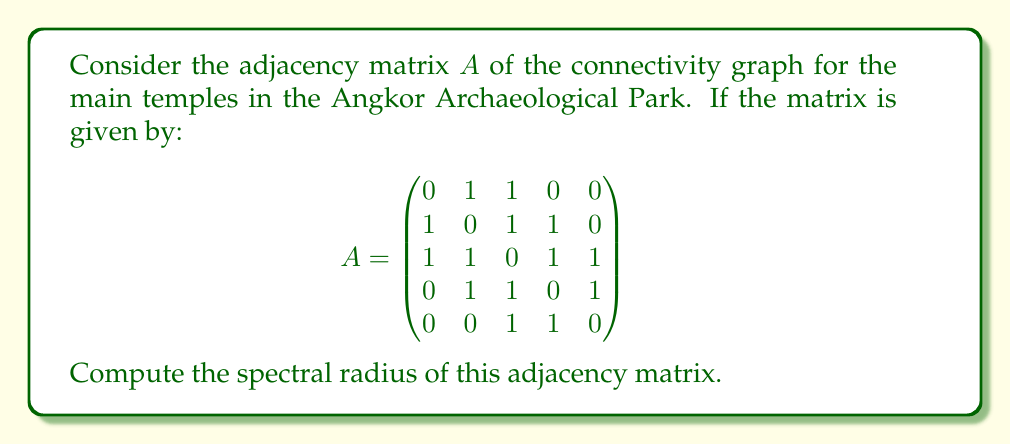Can you answer this question? To find the spectral radius of the adjacency matrix $A$, we need to follow these steps:

1) The spectral radius is the largest absolute value of the eigenvalues of $A$.

2) To find the eigenvalues, we need to solve the characteristic equation:
   $\det(A - \lambda I) = 0$

3) Expanding the determinant:
   $$\det\begin{pmatrix}
   -\lambda & 1 & 1 & 0 & 0 \\
   1 & -\lambda & 1 & 1 & 0 \\
   1 & 1 & -\lambda & 1 & 1 \\
   0 & 1 & 1 & -\lambda & 1 \\
   0 & 0 & 1 & 1 & -\lambda
   \end{pmatrix} = 0$$

4) This yields the characteristic polynomial:
   $\lambda^5 - 7\lambda^3 - 4\lambda^2 + 3\lambda + 1 = 0$

5) The roots of this polynomial are the eigenvalues. While finding the exact roots is complex, we can use numerical methods to approximate them:
   $\lambda_1 \approx 2.5615$
   $\lambda_2 \approx -1.7321$
   $\lambda_3 \approx 0.5559$
   $\lambda_4 \approx -0.6927$
   $\lambda_5 \approx 0.3074$

6) The spectral radius is the largest absolute value among these eigenvalues, which is $|\lambda_1| \approx 2.5615$.

This value represents the maximum influence or connectivity in the temple complex network, reflecting the intricate architectural and cultural connections in the Angkor Archaeological Park.
Answer: $2.5615$ (approximate) 